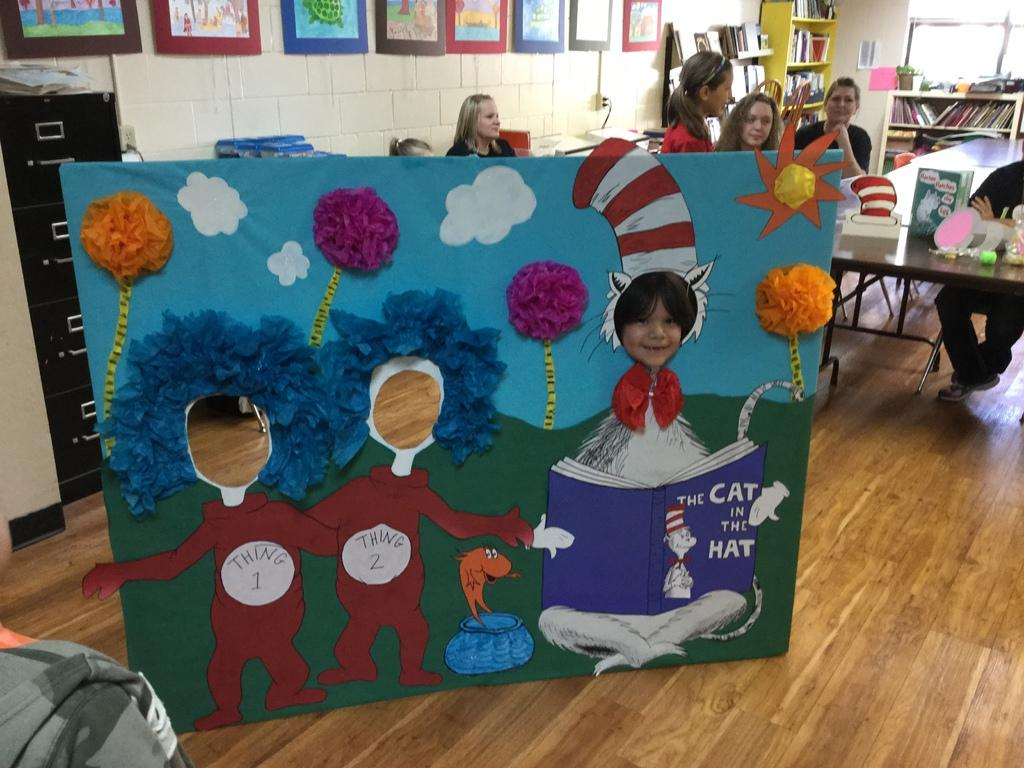<image>
Share a concise interpretation of the image provided. A kid putting their face through a cat in the hat exhibit 